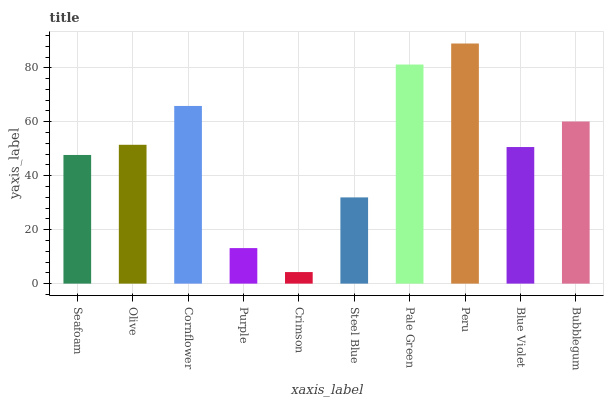Is Crimson the minimum?
Answer yes or no. Yes. Is Peru the maximum?
Answer yes or no. Yes. Is Olive the minimum?
Answer yes or no. No. Is Olive the maximum?
Answer yes or no. No. Is Olive greater than Seafoam?
Answer yes or no. Yes. Is Seafoam less than Olive?
Answer yes or no. Yes. Is Seafoam greater than Olive?
Answer yes or no. No. Is Olive less than Seafoam?
Answer yes or no. No. Is Olive the high median?
Answer yes or no. Yes. Is Blue Violet the low median?
Answer yes or no. Yes. Is Steel Blue the high median?
Answer yes or no. No. Is Pale Green the low median?
Answer yes or no. No. 